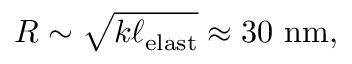<formula> <loc_0><loc_0><loc_500><loc_500>R \sim \sqrt { k \ell _ { e l a s t } } \approx 3 0 n m ,</formula> 